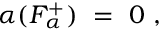Convert formula to latex. <formula><loc_0><loc_0><loc_500><loc_500>\alpha ( F _ { \alpha } ^ { + } ) = 0 ,</formula> 